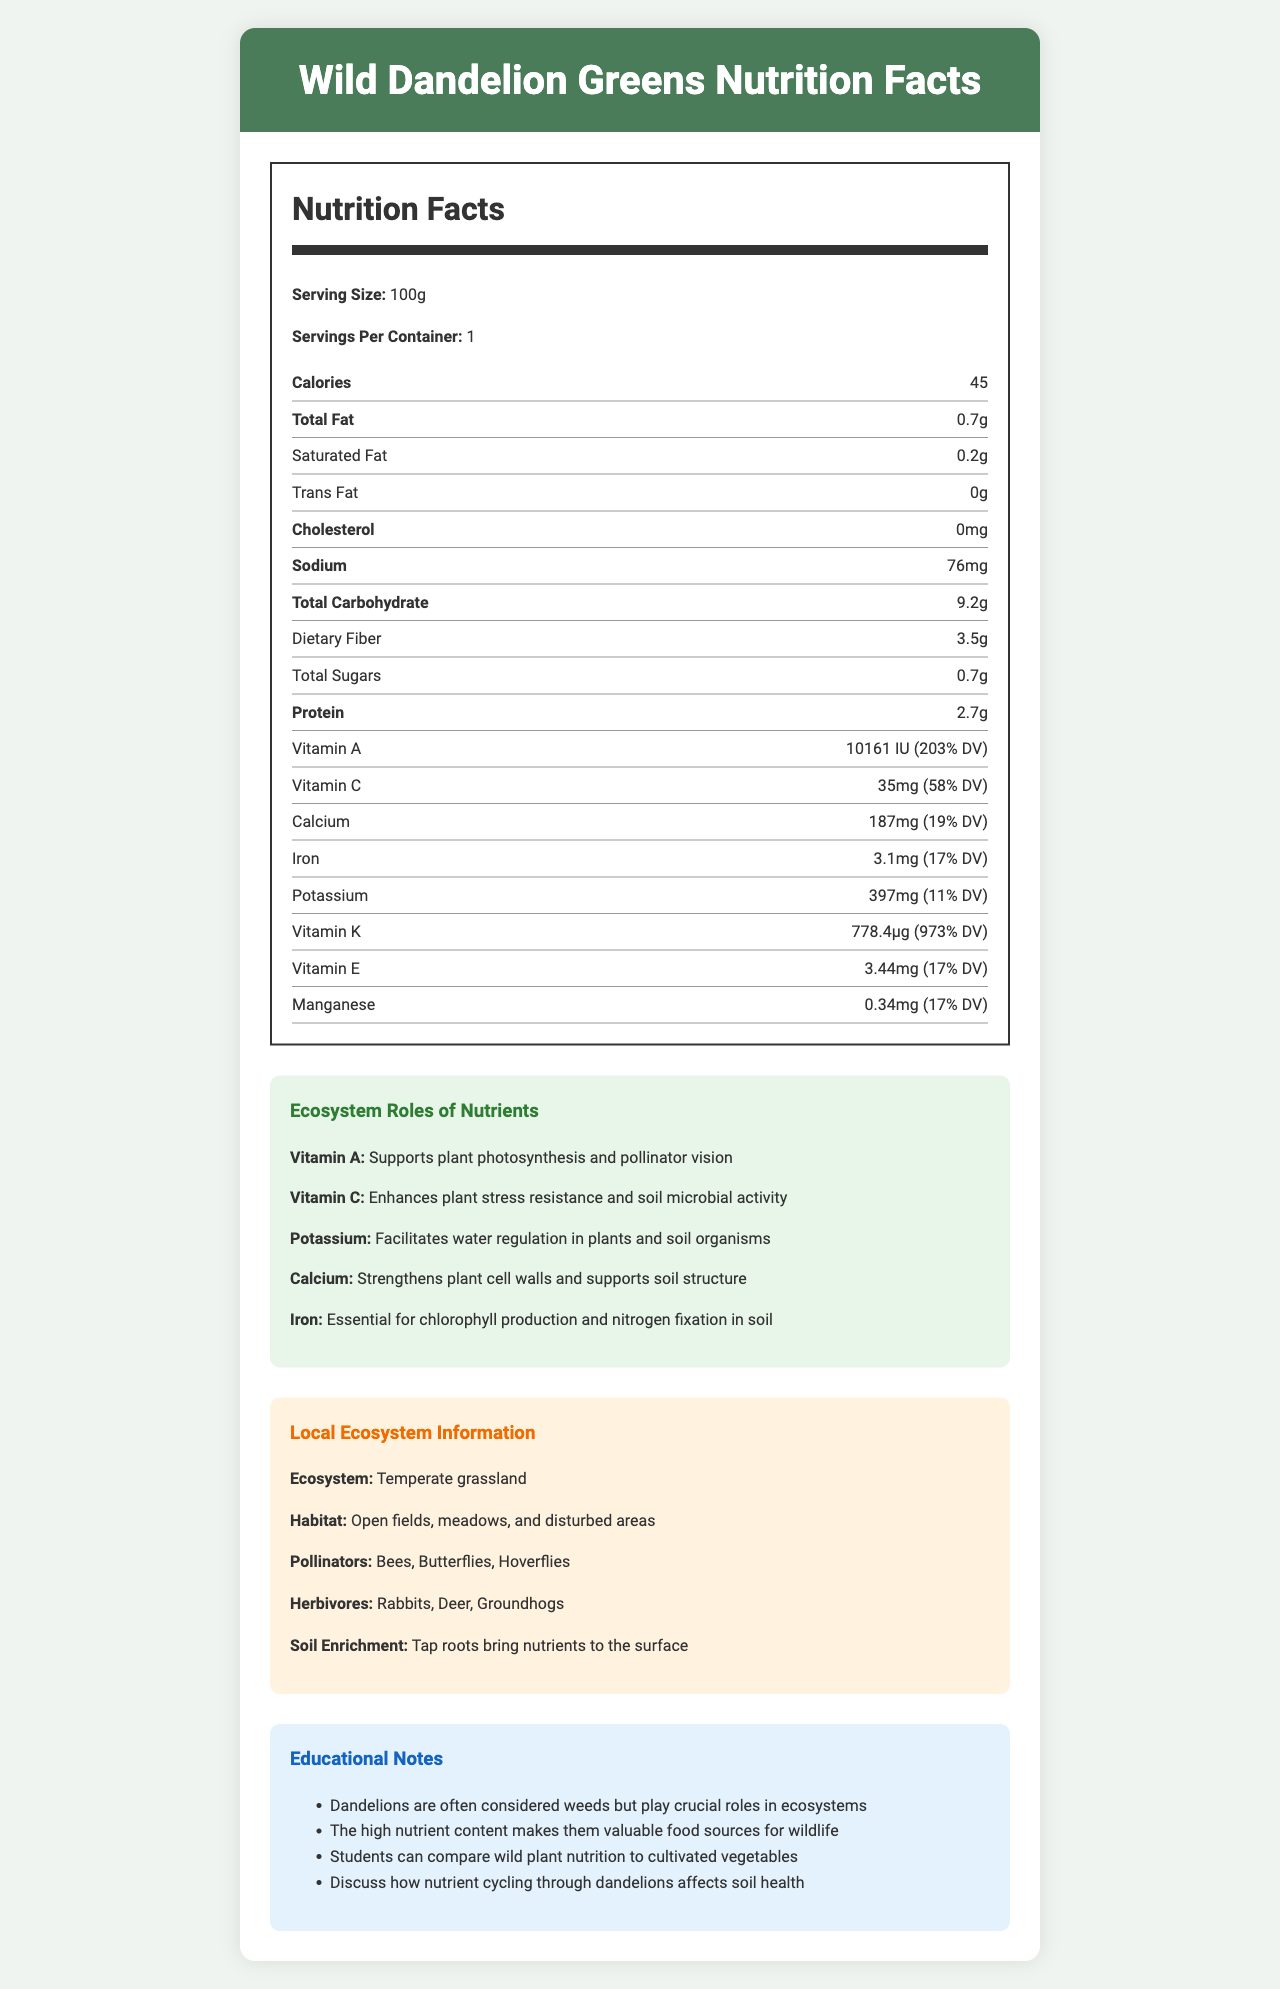what is the serving size for Wild Dandelion Greens? The serving size is directly stated in the Nutrition Facts section.
Answer: 100g how many calories are in one serving? The number of calories per serving is listed as 45 in the Nutrition Facts section.
Answer: 45 what percentage of the daily value (DV) for Vitamin A is provided by one serving? The Vitamin A content is listed as 10161 IU, which is 203% of the daily value.
Answer: 203% what is the main role of Potassium in the ecosystem, according to the document? The role of Potassium is detailed in the "Ecosystem Roles of Nutrients" section.
Answer: Facilitates water regulation in plants and soil organisms list at least two herbivores that may consume Wild Dandelion Greens. The document lists Rabbits, Deer, and Groundhogs as herbivores in the Local Ecosystem Information section.
Answer: Rabbits, Deer what is the total carbohydrate content per serving? A. 8.2g B. 9.2g C. 7.2g D. 10g The total carbohydrate content is listed as 9.2g in the Nutrition Facts section.
Answer: B which vitamin is present in the highest percentage of the daily value? A. Vitamin A B. Vitamin C C. Vitamin K D. Vitamin E Vitamin K is 973% DV, which is the highest compared to others listed.
Answer: C does the document state that Wild Dandelion Greens contain any cholesterol? Yes/No The Nutrition Facts section clearly states that the cholesterol content is 0mg.
Answer: No summarize the main points of the document. This captures the document's comprehensive information on nutritional value, ecological roles, and educational significance.
Answer: The document provides nutritional information on Wild Dandelion Greens, highlighting their rich content in vitamins and minerals. It also explains the roles of these nutrients in the ecosystem, details the local ecosystem and habitat where dandelions grow, and emphasizes their importance in soil enrichment and as a food source for pollinators and herbivores. Furthermore, educational notes suggest the comparison of wild plants to cultivated vegetables and discuss nutrient cycling. what month is ideal for collecting Wild Dandelion Greens? The document does not specify any particular month for collecting Wild Dandelion Greens.
Answer: Not enough information 